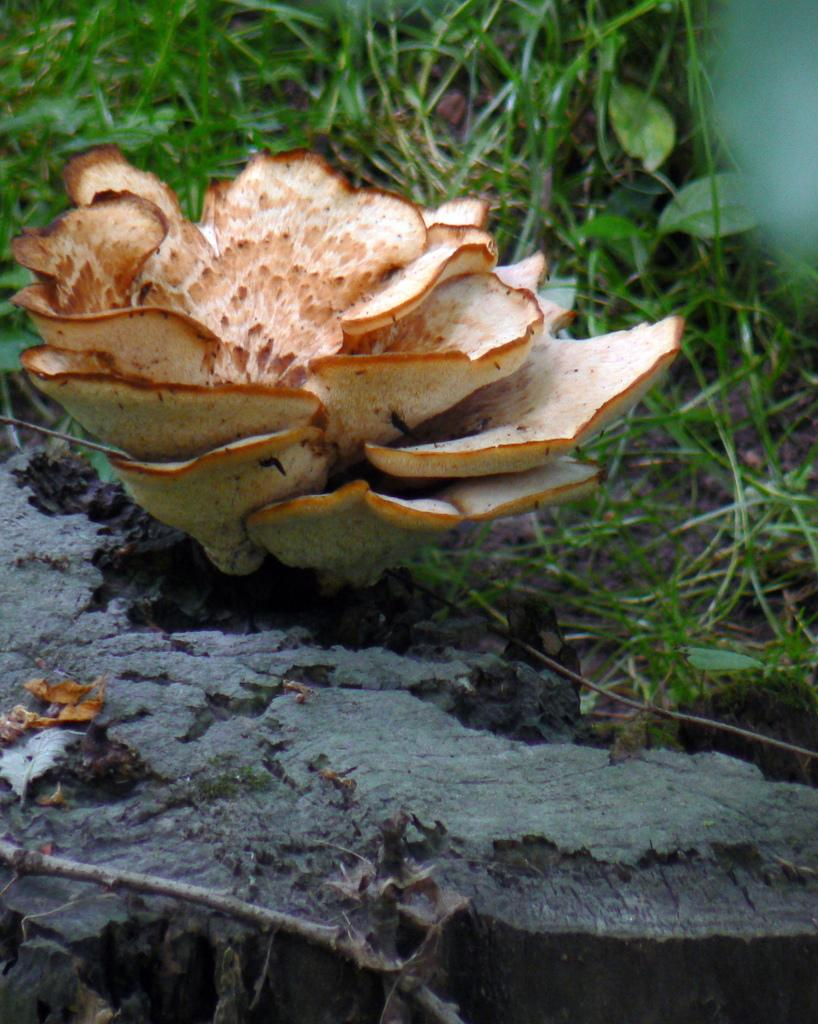What is the main subject of the image? The main subject of the image is a mushroom. Where is the mushroom located? The mushroom is on a grassland. How much money does the rabbit have in the image? There is no rabbit present in the image, so it is not possible to determine how much money it might have. 